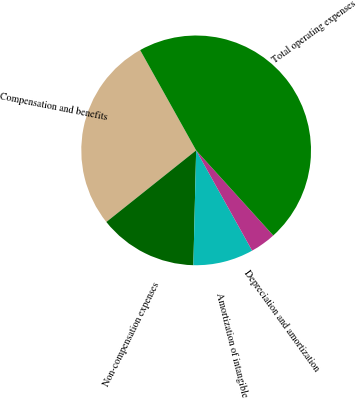Convert chart. <chart><loc_0><loc_0><loc_500><loc_500><pie_chart><fcel>Compensation and benefits<fcel>Non-compensation expenses<fcel>Amortization of intangible<fcel>Depreciation and amortization<fcel>Total operating expenses<nl><fcel>27.61%<fcel>13.9%<fcel>8.49%<fcel>3.61%<fcel>46.39%<nl></chart> 